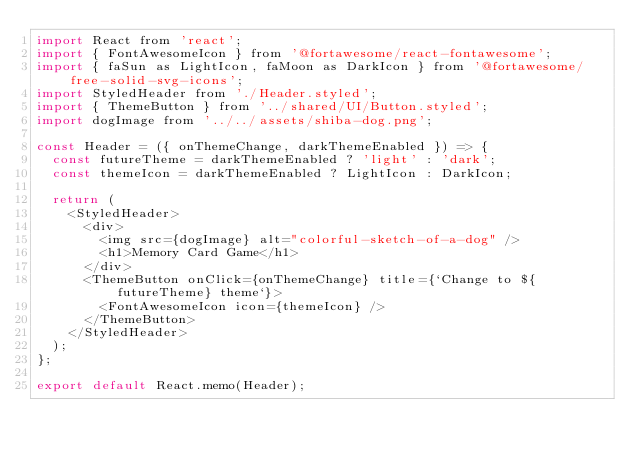Convert code to text. <code><loc_0><loc_0><loc_500><loc_500><_JavaScript_>import React from 'react';
import { FontAwesomeIcon } from '@fortawesome/react-fontawesome';
import { faSun as LightIcon, faMoon as DarkIcon } from '@fortawesome/free-solid-svg-icons';
import StyledHeader from './Header.styled';
import { ThemeButton } from '../shared/UI/Button.styled';
import dogImage from '../../assets/shiba-dog.png';

const Header = ({ onThemeChange, darkThemeEnabled }) => {
  const futureTheme = darkThemeEnabled ? 'light' : 'dark';
  const themeIcon = darkThemeEnabled ? LightIcon : DarkIcon;

  return (
    <StyledHeader>
      <div>
        <img src={dogImage} alt="colorful-sketch-of-a-dog" />
        <h1>Memory Card Game</h1>
      </div>
      <ThemeButton onClick={onThemeChange} title={`Change to ${futureTheme} theme`}>
        <FontAwesomeIcon icon={themeIcon} />
      </ThemeButton>
    </StyledHeader>
  );
};

export default React.memo(Header);
</code> 